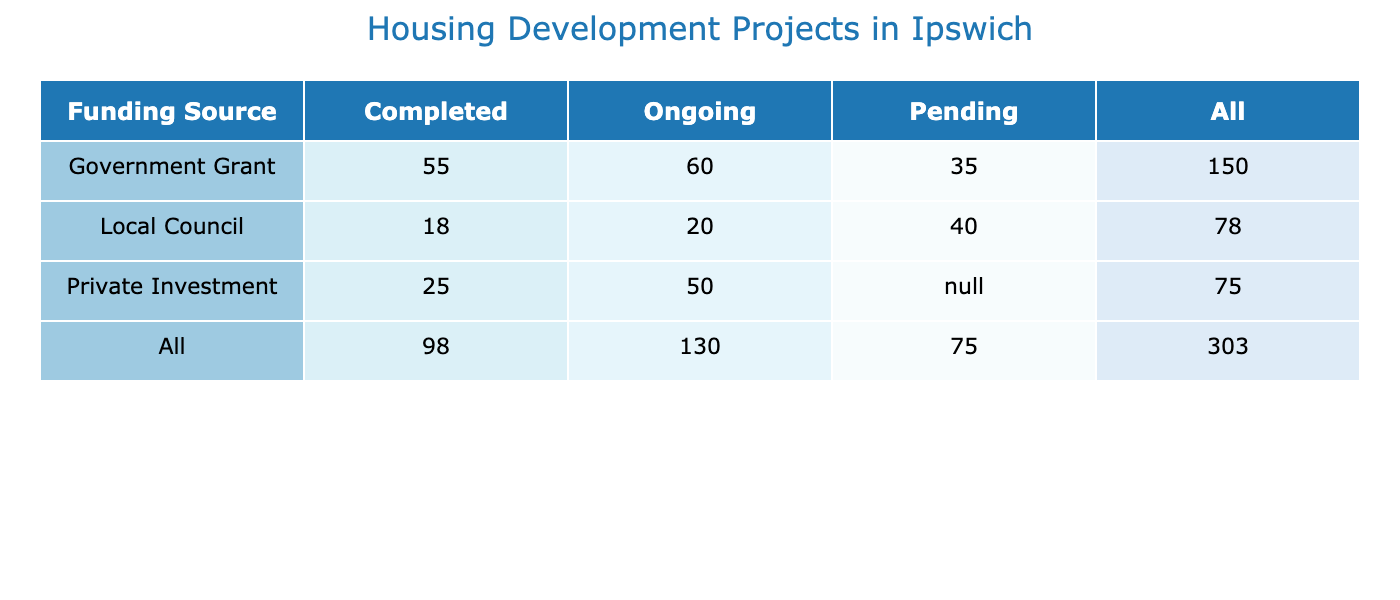What is the total number of housing units funded by Private Investment? From the table, we look at the 'Private Investment' row and sum the units from 'Ongoing' and 'Completed' status. The completed status has 15 (St. Matthew's Lofts) and the ongoing status has 50 (Queensway Development), resulting in a total of 15 + 50 = 65 units.
Answer: 65 How many projects are currently ongoing? We look for the 'Ongoing' column and count the number of entries. There are three ongoing projects: Queensway Development (50 units), High Street Regeneration (20 units), and East Ipswich Community Flats (60 units). Therefore, the total number of ongoing projects is 3.
Answer: 3 Is there any project still pending under the Government Grant funding? In the table, we check the 'Government Grant' row for any 'Pending' status. We find that Willowbank Homes is in the pending status, indicating that there is at least one project pending under this funding source.
Answer: Yes What is the total number of completed projects funded by Local Council? From the 'Local Council' row in the table, we find completed projects: Mill Road Estates (18 units) and Oakfield Rise (40 units). Thus, adding these two, we get 18 + 40 = 58.
Answer: 58 Which funding source has the highest number of units overall? We need to sum the units for each funding source. For Government Grant: 30 + 25 + 60 + 35 = 150; for Private Investment: 10 + 15 + 50 = 75; for Local Council: 18 + 20 + 40 = 78. The Government Grant has the highest total with 150 units.
Answer: Government Grant In total, how many units are associated with projects that are completed? We examine the table for all projects marked 'Completed'. These projects are Westbury Court (30 units), Castle Hill Apartments (25 units), St. Matthew's Lofts (15 units), Greenwood Housing (10 units), and Mill Road Estates (18 units). Adding these gives us 30 + 25 + 15 + 10 + 18 = 98 units.
Answer: 98 What is the ratio of completed projects to ongoing projects funded by Local Council? For Local Council, there are 2 completed projects (Mill Road Estates and Oakfield Rise) and 1 ongoing project (High Street Regeneration). Therefore, the ratio is 2:1.
Answer: 2:1 Are there more units in completed projects than in ongoing projects across all funding sources? First, we calculate the units in completed projects: 30 + 25 + 15 + 10 + 18 = 98; then for ongoing projects: 50 + 20 + 60 = 130. Since 98 (completed) is less than 130 (ongoing), the answer is no.
Answer: No 